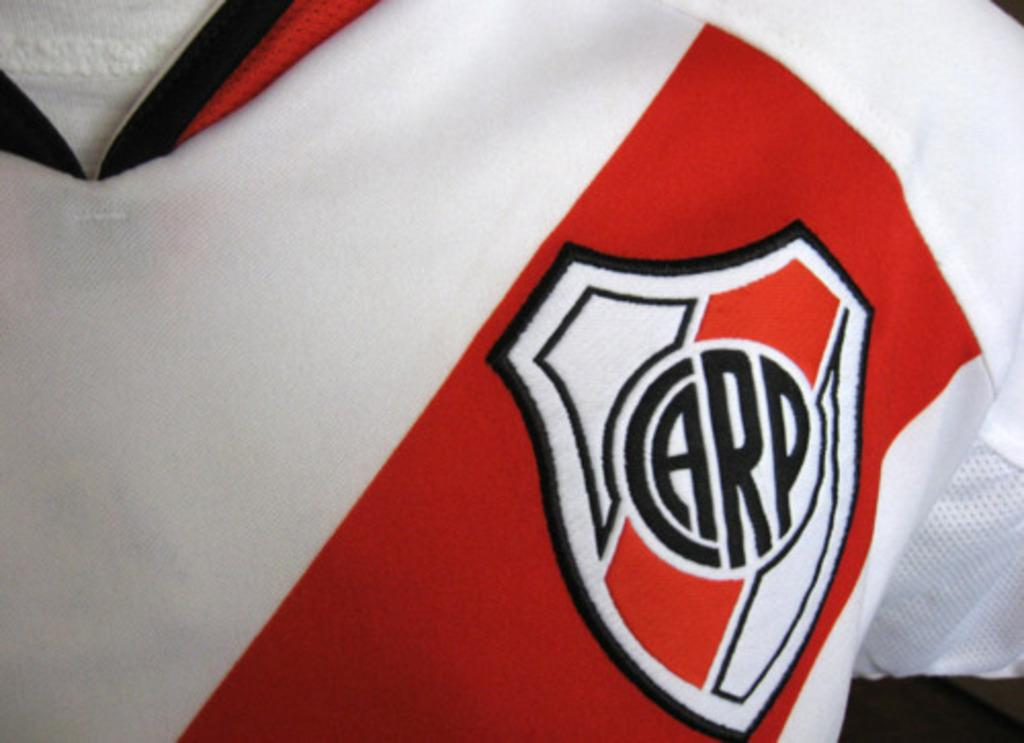<image>
Present a compact description of the photo's key features. close up of part of red and white jersey with emblem that has carp in middle of it 